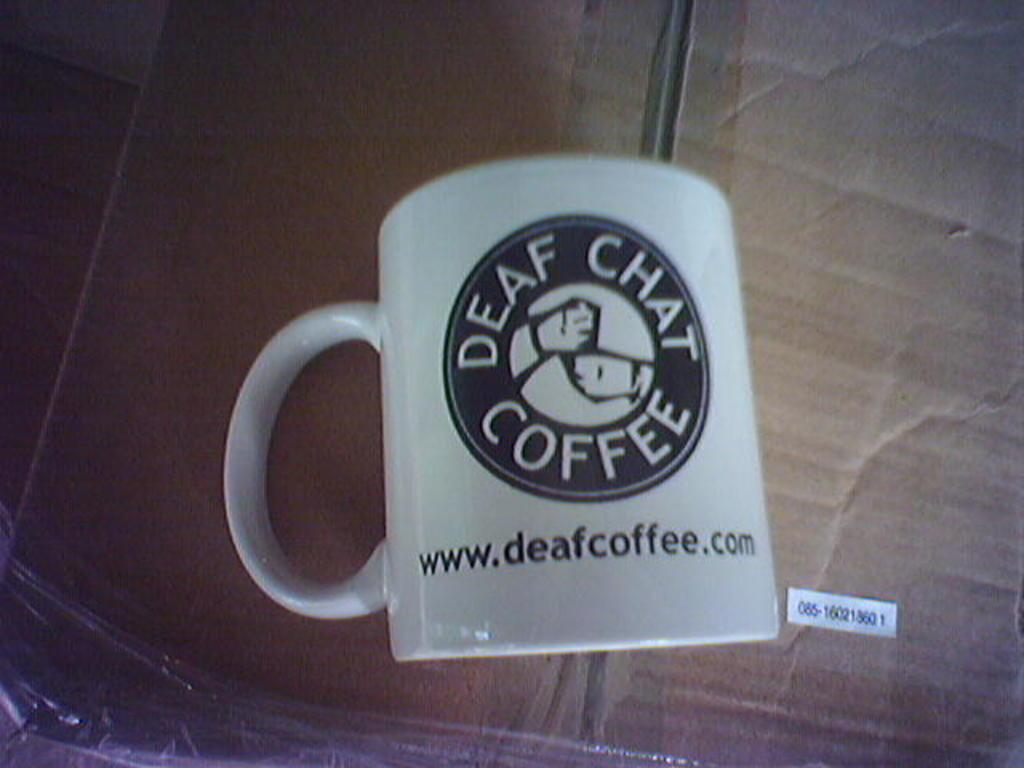<image>
Create a compact narrative representing the image presented. A Deaf Chat Coffee mug on top of a box 